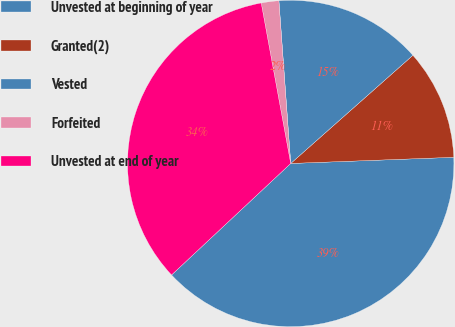<chart> <loc_0><loc_0><loc_500><loc_500><pie_chart><fcel>Unvested at beginning of year<fcel>Granted(2)<fcel>Vested<fcel>Forfeited<fcel>Unvested at end of year<nl><fcel>38.63%<fcel>10.93%<fcel>14.62%<fcel>1.74%<fcel>34.08%<nl></chart> 